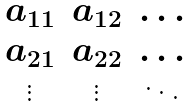Convert formula to latex. <formula><loc_0><loc_0><loc_500><loc_500>\begin{matrix} a _ { 1 1 } & a _ { 1 2 } & \dots \\ a _ { 2 1 } & a _ { 2 2 } & \dots \\ \vdots & \vdots & \ddots \\ \end{matrix}</formula> 